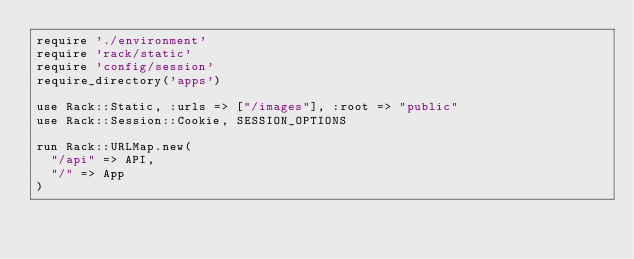Convert code to text. <code><loc_0><loc_0><loc_500><loc_500><_Ruby_>require './environment'
require 'rack/static'
require 'config/session'
require_directory('apps')

use Rack::Static, :urls => ["/images"], :root => "public"
use Rack::Session::Cookie, SESSION_OPTIONS

run Rack::URLMap.new(
  "/api" => API,
  "/" => App
)
</code> 